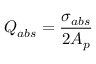Convert formula to latex. <formula><loc_0><loc_0><loc_500><loc_500>Q _ { a b s } = \frac { \sigma _ { a b s } } { 2 A _ { p } }</formula> 